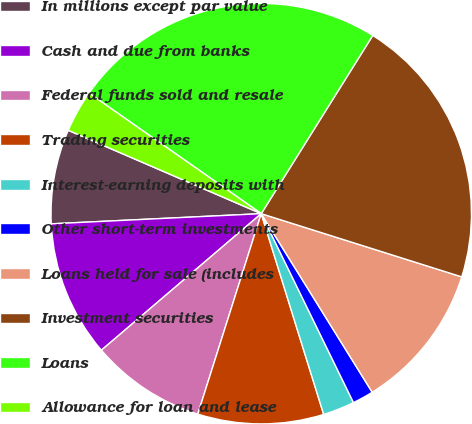Convert chart. <chart><loc_0><loc_0><loc_500><loc_500><pie_chart><fcel>In millions except par value<fcel>Cash and due from banks<fcel>Federal funds sold and resale<fcel>Trading securities<fcel>Interest-earning deposits with<fcel>Other short-term investments<fcel>Loans held for sale (includes<fcel>Investment securities<fcel>Loans<fcel>Allowance for loan and lease<nl><fcel>7.26%<fcel>10.48%<fcel>8.87%<fcel>9.68%<fcel>2.43%<fcel>1.62%<fcel>11.29%<fcel>20.96%<fcel>24.18%<fcel>3.23%<nl></chart> 